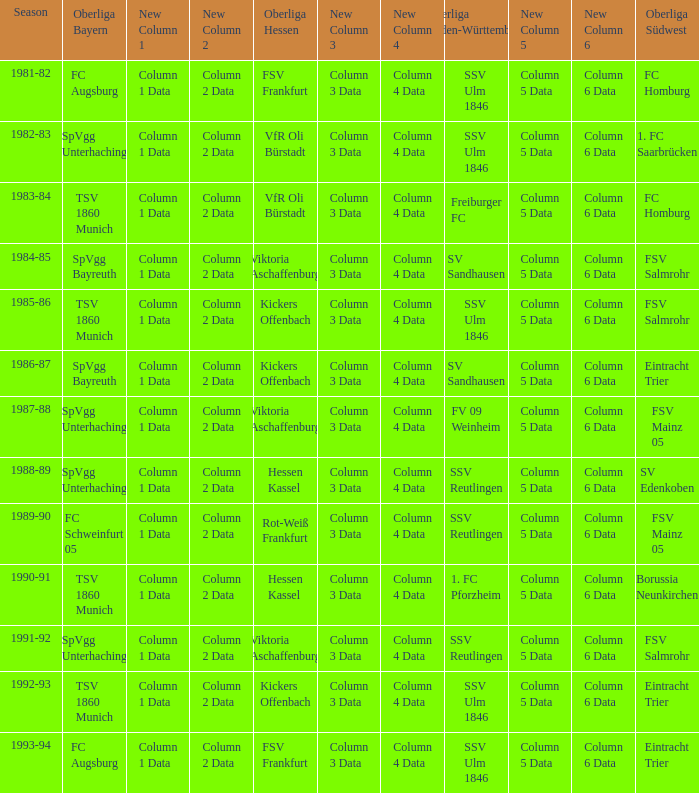Parse the full table. {'header': ['Season', 'Oberliga Bayern', 'New Column 1', 'New Column 2', 'Oberliga Hessen', 'New Column 3', 'New Column 4', 'Oberliga Baden-Württemberg', 'New Column 5', 'New Column 6', 'Oberliga Südwest'], 'rows': [['1981-82', 'FC Augsburg', 'Column 1 Data', 'Column 2 Data', 'FSV Frankfurt', 'Column 3 Data', 'Column 4 Data', 'SSV Ulm 1846', 'Column 5 Data', 'Column 6 Data', 'FC Homburg'], ['1982-83', 'SpVgg Unterhaching', 'Column 1 Data', 'Column 2 Data', 'VfR Oli Bürstadt', 'Column 3 Data', 'Column 4 Data', 'SSV Ulm 1846', 'Column 5 Data', 'Column 6 Data', '1. FC Saarbrücken'], ['1983-84', 'TSV 1860 Munich', 'Column 1 Data', 'Column 2 Data', 'VfR Oli Bürstadt', 'Column 3 Data', 'Column 4 Data', 'Freiburger FC', 'Column 5 Data', 'Column 6 Data', 'FC Homburg'], ['1984-85', 'SpVgg Bayreuth', 'Column 1 Data', 'Column 2 Data', 'Viktoria Aschaffenburg', 'Column 3 Data', 'Column 4 Data', 'SV Sandhausen', 'Column 5 Data', 'Column 6 Data', 'FSV Salmrohr'], ['1985-86', 'TSV 1860 Munich', 'Column 1 Data', 'Column 2 Data', 'Kickers Offenbach', 'Column 3 Data', 'Column 4 Data', 'SSV Ulm 1846', 'Column 5 Data', 'Column 6 Data', 'FSV Salmrohr'], ['1986-87', 'SpVgg Bayreuth', 'Column 1 Data', 'Column 2 Data', 'Kickers Offenbach', 'Column 3 Data', 'Column 4 Data', 'SV Sandhausen', 'Column 5 Data', 'Column 6 Data', 'Eintracht Trier'], ['1987-88', 'SpVgg Unterhaching', 'Column 1 Data', 'Column 2 Data', 'Viktoria Aschaffenburg', 'Column 3 Data', 'Column 4 Data', 'FV 09 Weinheim', 'Column 5 Data', 'Column 6 Data', 'FSV Mainz 05'], ['1988-89', 'SpVgg Unterhaching', 'Column 1 Data', 'Column 2 Data', 'Hessen Kassel', 'Column 3 Data', 'Column 4 Data', 'SSV Reutlingen', 'Column 5 Data', 'Column 6 Data', 'SV Edenkoben'], ['1989-90', 'FC Schweinfurt 05', 'Column 1 Data', 'Column 2 Data', 'Rot-Weiß Frankfurt', 'Column 3 Data', 'Column 4 Data', 'SSV Reutlingen', 'Column 5 Data', 'Column 6 Data', 'FSV Mainz 05'], ['1990-91', 'TSV 1860 Munich', 'Column 1 Data', 'Column 2 Data', 'Hessen Kassel', 'Column 3 Data', 'Column 4 Data', '1. FC Pforzheim', 'Column 5 Data', 'Column 6 Data', 'Borussia Neunkirchen'], ['1991-92', 'SpVgg Unterhaching', 'Column 1 Data', 'Column 2 Data', 'Viktoria Aschaffenburg', 'Column 3 Data', 'Column 4 Data', 'SSV Reutlingen', 'Column 5 Data', 'Column 6 Data', 'FSV Salmrohr'], ['1992-93', 'TSV 1860 Munich', 'Column 1 Data', 'Column 2 Data', 'Kickers Offenbach', 'Column 3 Data', 'Column 4 Data', 'SSV Ulm 1846', 'Column 5 Data', 'Column 6 Data', 'Eintracht Trier'], ['1993-94', 'FC Augsburg', 'Column 1 Data', 'Column 2 Data', 'FSV Frankfurt', 'Column 3 Data', 'Column 4 Data', 'SSV Ulm 1846', 'Column 5 Data', 'Column 6 Data', 'Eintracht Trier']]} Which Season ha spvgg bayreuth and eintracht trier? 1986-87. 